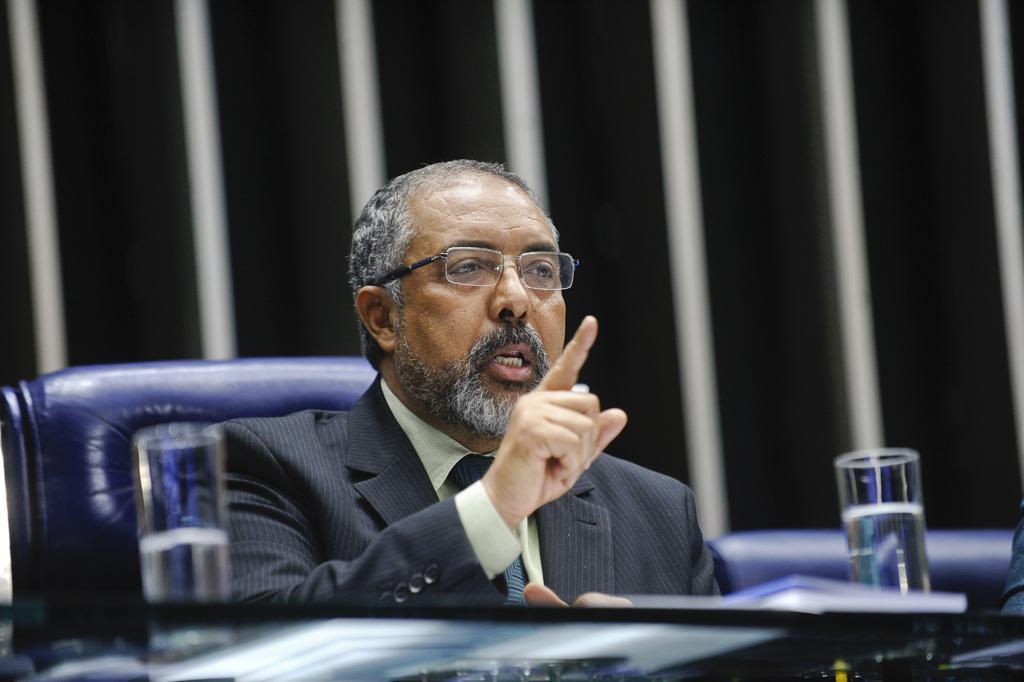Could you give a brief overview of what you see in this image? In this image there are chairs, person, glasses, water and objects. A person is sitting on a chair. In the background of the image it is blurry.  